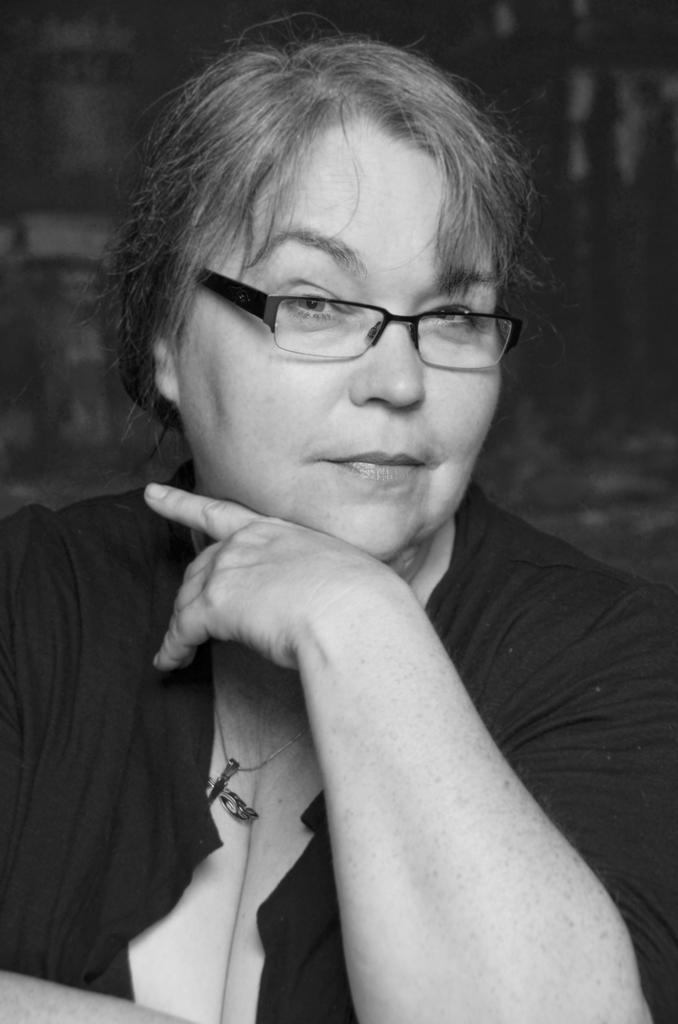What is the color scheme of the image? The image is black and white. Who is present in the image? There is a woman in the image. What accessory is the woman wearing? The woman is wearing spectacles. How is the background behind the woman depicted? The background behind the woman is blurred. What type of shoes is the woman wearing in the image? There is no information about shoes in the image, as it is black and white and focuses on the woman wearing spectacles with a blurred background. 